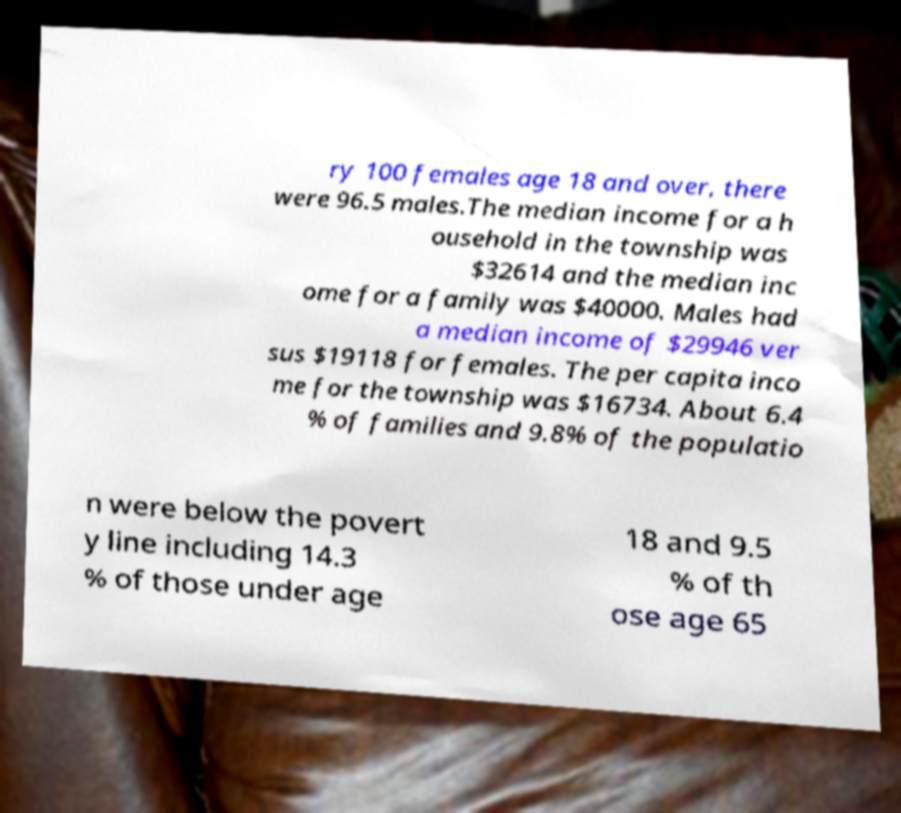Please identify and transcribe the text found in this image. ry 100 females age 18 and over, there were 96.5 males.The median income for a h ousehold in the township was $32614 and the median inc ome for a family was $40000. Males had a median income of $29946 ver sus $19118 for females. The per capita inco me for the township was $16734. About 6.4 % of families and 9.8% of the populatio n were below the povert y line including 14.3 % of those under age 18 and 9.5 % of th ose age 65 